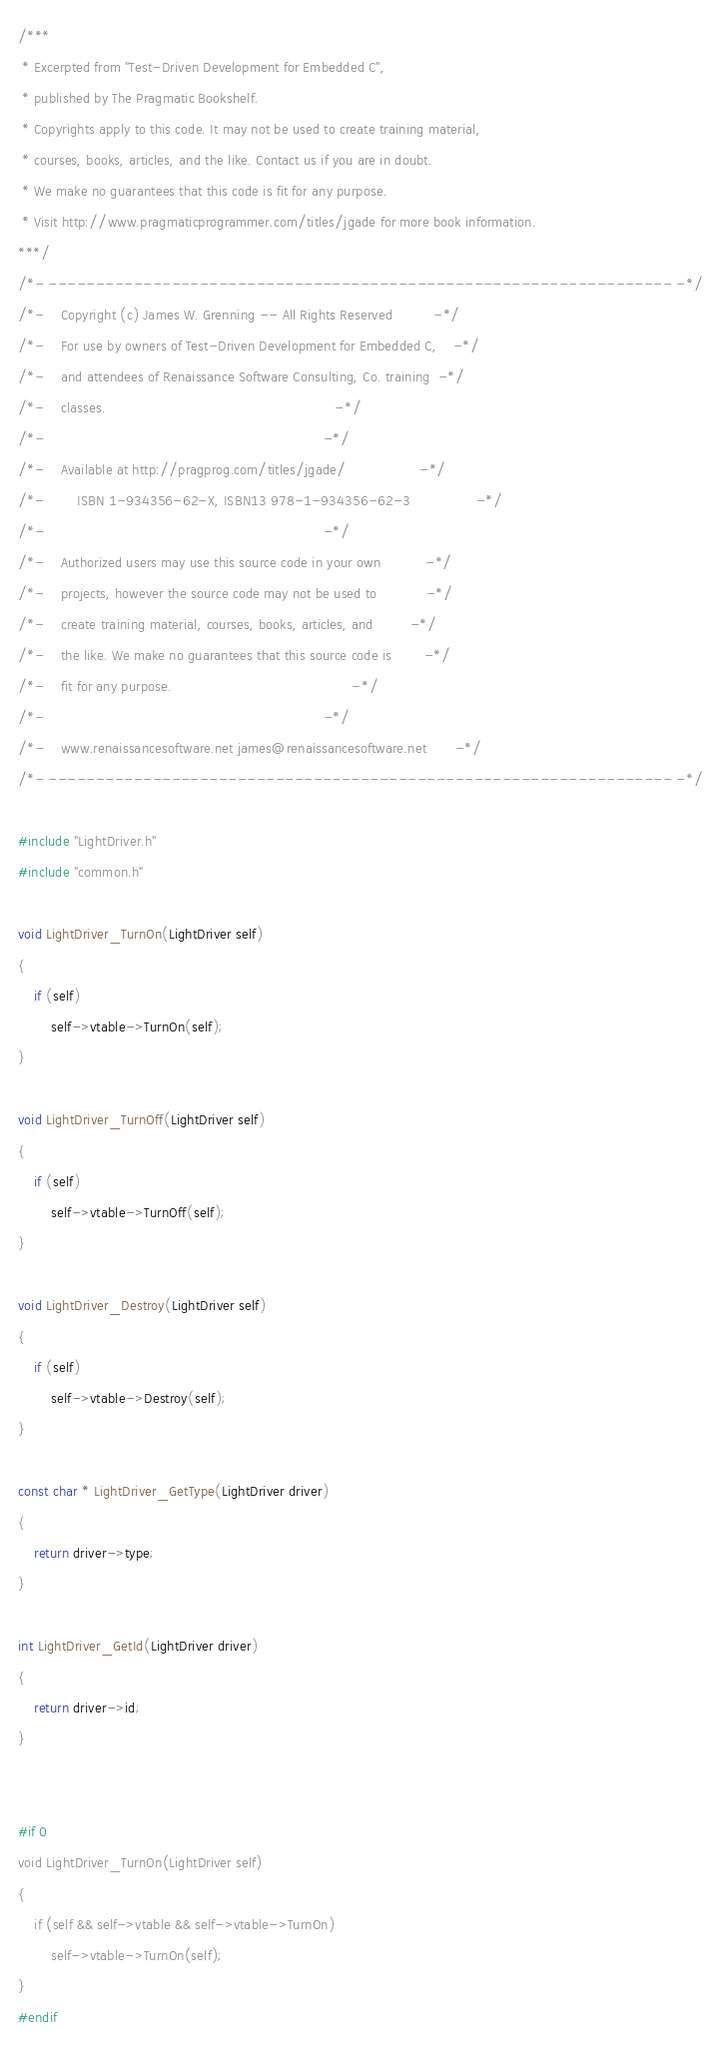<code> <loc_0><loc_0><loc_500><loc_500><_C_>/***
 * Excerpted from "Test-Driven Development for Embedded C",
 * published by The Pragmatic Bookshelf.
 * Copyrights apply to this code. It may not be used to create training material, 
 * courses, books, articles, and the like. Contact us if you are in doubt.
 * We make no guarantees that this code is fit for any purpose. 
 * Visit http://www.pragmaticprogrammer.com/titles/jgade for more book information.
***/
/*- ------------------------------------------------------------------ -*/
/*-    Copyright (c) James W. Grenning -- All Rights Reserved          -*/
/*-    For use by owners of Test-Driven Development for Embedded C,    -*/
/*-    and attendees of Renaissance Software Consulting, Co. training  -*/
/*-    classes.                                                        -*/
/*-                                                                    -*/
/*-    Available at http://pragprog.com/titles/jgade/                  -*/
/*-        ISBN 1-934356-62-X, ISBN13 978-1-934356-62-3                -*/
/*-                                                                    -*/
/*-    Authorized users may use this source code in your own           -*/
/*-    projects, however the source code may not be used to            -*/
/*-    create training material, courses, books, articles, and         -*/
/*-    the like. We make no guarantees that this source code is        -*/
/*-    fit for any purpose.                                            -*/
/*-                                                                    -*/
/*-    www.renaissancesoftware.net james@renaissancesoftware.net       -*/
/*- ------------------------------------------------------------------ -*/

#include "LightDriver.h"
#include "common.h"

void LightDriver_TurnOn(LightDriver self)
{
    if (self)
        self->vtable->TurnOn(self);
}

void LightDriver_TurnOff(LightDriver self)
{
    if (self)
        self->vtable->TurnOff(self);
}

void LightDriver_Destroy(LightDriver self)
{
    if (self)
        self->vtable->Destroy(self);
}

const char * LightDriver_GetType(LightDriver driver)
{
    return driver->type;
}

int LightDriver_GetId(LightDriver driver)
{
    return driver->id;
}


#if 0 
void LightDriver_TurnOn(LightDriver self)
{
    if (self && self->vtable && self->vtable->TurnOn)
        self->vtable->TurnOn(self);
}
#endif 



</code> 